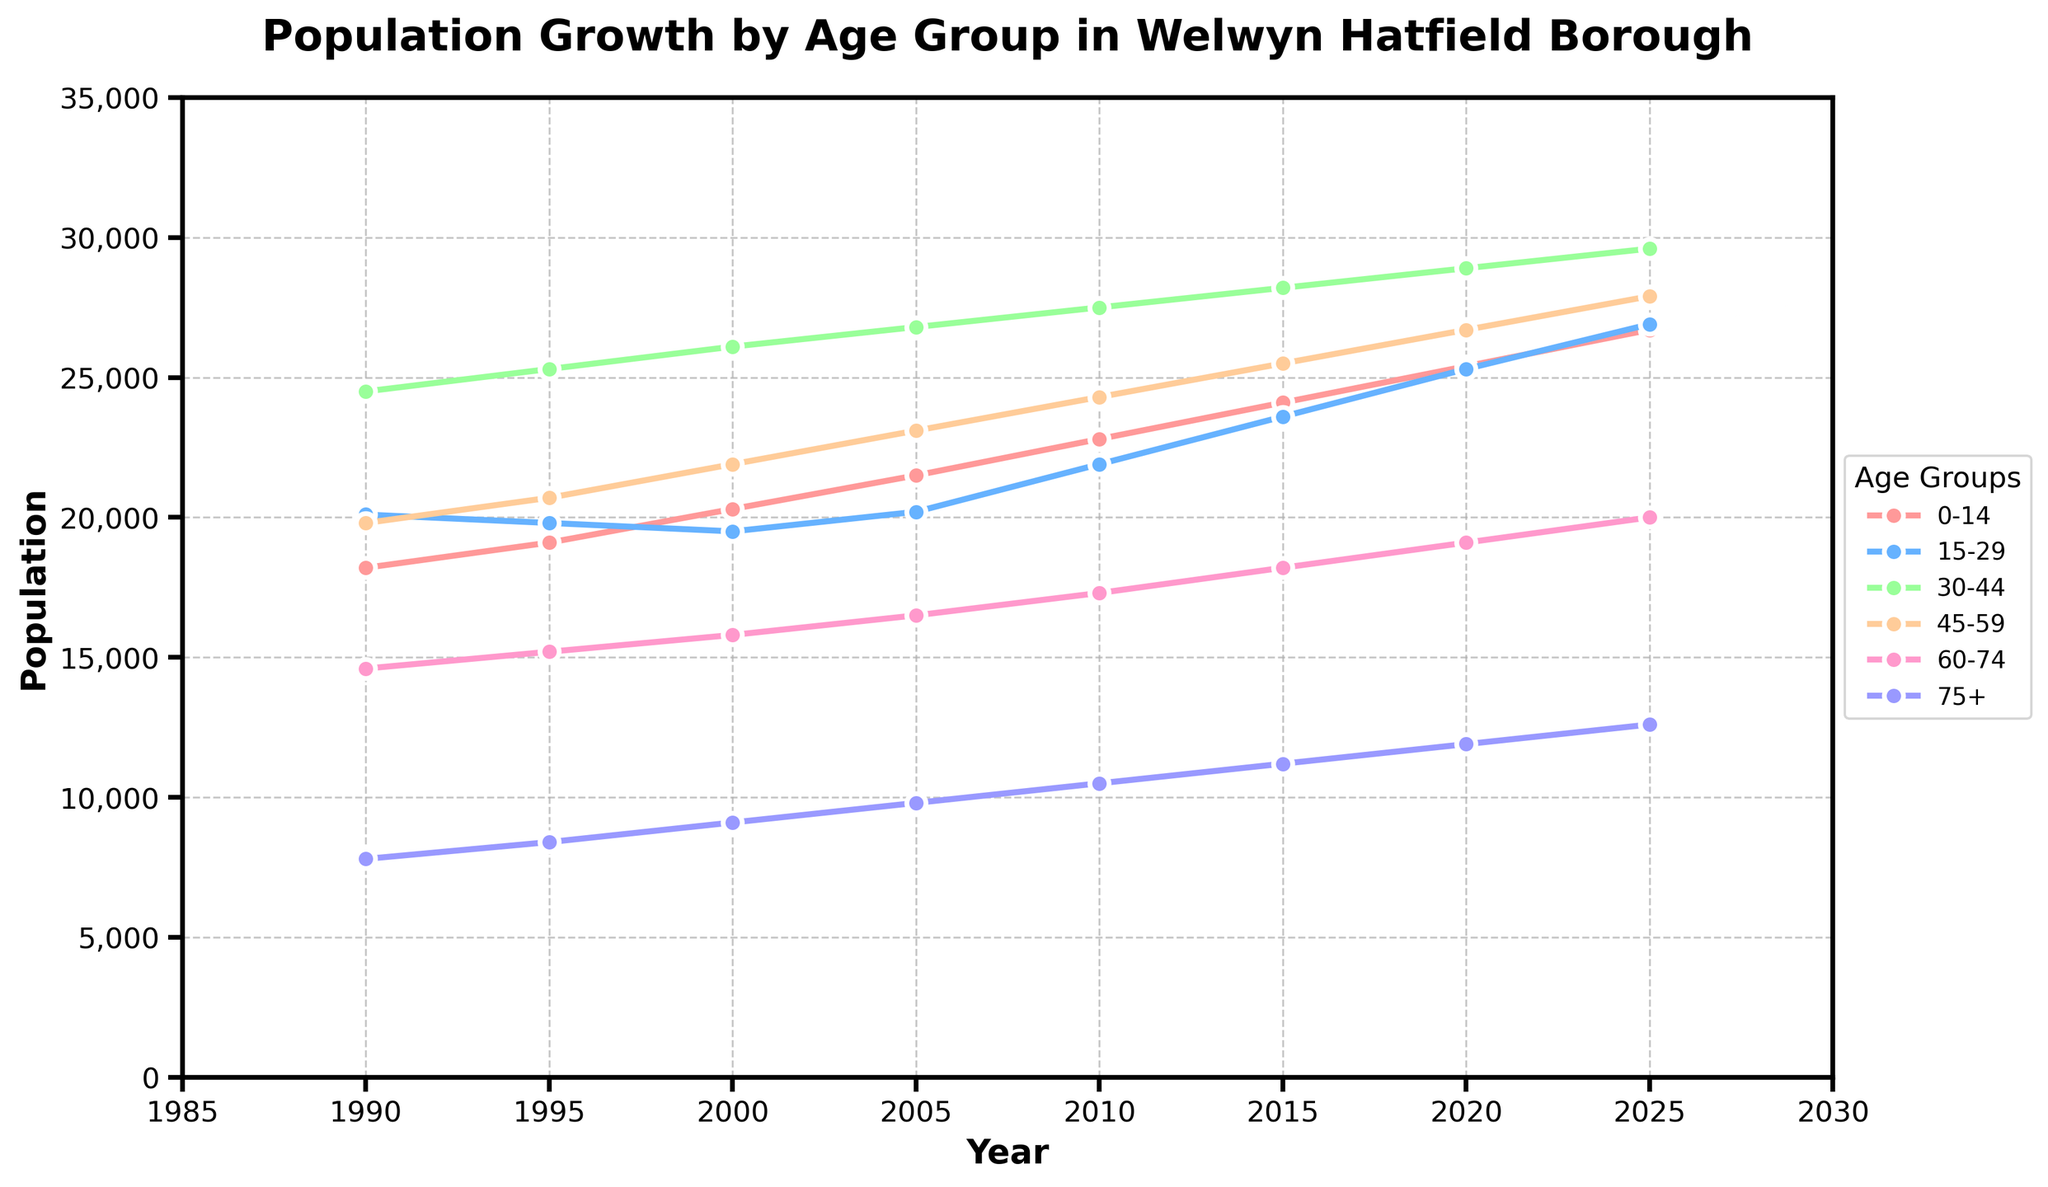What is the population for the age group 0-14 in 2000? The figure shows that the population for the age group 0-14 in the year 2000 is marked with a point on the line corresponding to the color for this age group. The y-axis value at this point indicates the population.
Answer: 20300 Which age group had the highest population in 2010? To determine the age group with the highest population in 2010, compare the y-axis values for all age groups in the year 2010. Identify the line that reaches the highest point on the y-axis for that year.
Answer: 30-44 How did the population of the 75+ age group change from 1990 to 2025? Look at the points on the line for the 75+ age group in both 1990 and 2025. Compare the y-axis values at these points to see the change in population.
Answer: Increased from 7800 to 12600 What is the trend for the 15-29 age group over the given years? The 15-29 age group's line shows slight fluctuations. It decreased from 1990 to 2000, then increased steadily up to 2025. Examining the height and direction of the line provides this insight.
Answer: Fluctuating but overall increasing What is the sum of the populations of the 0-14 and 45-59 age groups in 2020? Find the populations for the 0-14 and 45-59 age groups in 2020 by checking their respective lines' y-axis values. Sum these values for the total.
Answer: 25400 + 26700 = 52100 Which age group showed the least growth from 1990 to 2025? Calculate the difference in population from 1990 to 2025 for all age groups. The age group with the smallest positive difference has the least growth.
Answer: 15-29 Is the population of the 30-44 age group greater than the combined population of the 60-74 and 75+ age groups in 2005? First, find the population for the 30-44 age group in 2005 and then sum the populations of the 60-74 and 75+ age groups in the same year. Compare the two values.
Answer: Yes, 26800 > (16500 + 9800) Which age group's population appears to have the steepest increase from 1990 to 2025? By observing the slopes of the lines for each age group, the steepest slope signifies the fastest increase. Examine the visual angles or the difference in heights between the starting and ending points.
Answer: 0-14 What is the average population of the 60-74 age group from 1990 to 2025? Sum the populations of the 60-74 age group for all years presented and divide by the number of years (8) to find the average population. (14600 + 15200 + 15800 + 16500 + 17300 + 18200 + 19100 + 20000) / 8
Answer: 17081.25 